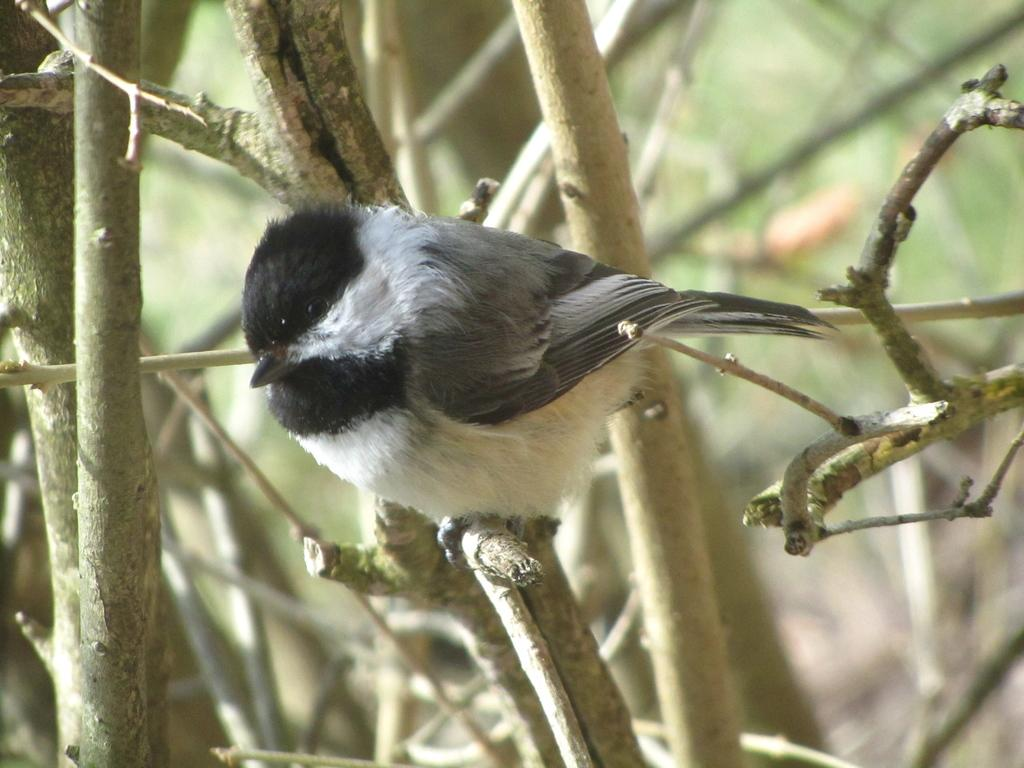What type of animal can be seen in the image? There is a bird in the image. Where is the bird located in the image? The bird is on the branch of a tree. What type of toothbrush is the bird using in the image? There is no toothbrush present in the image; it features a bird on the branch of a tree. 